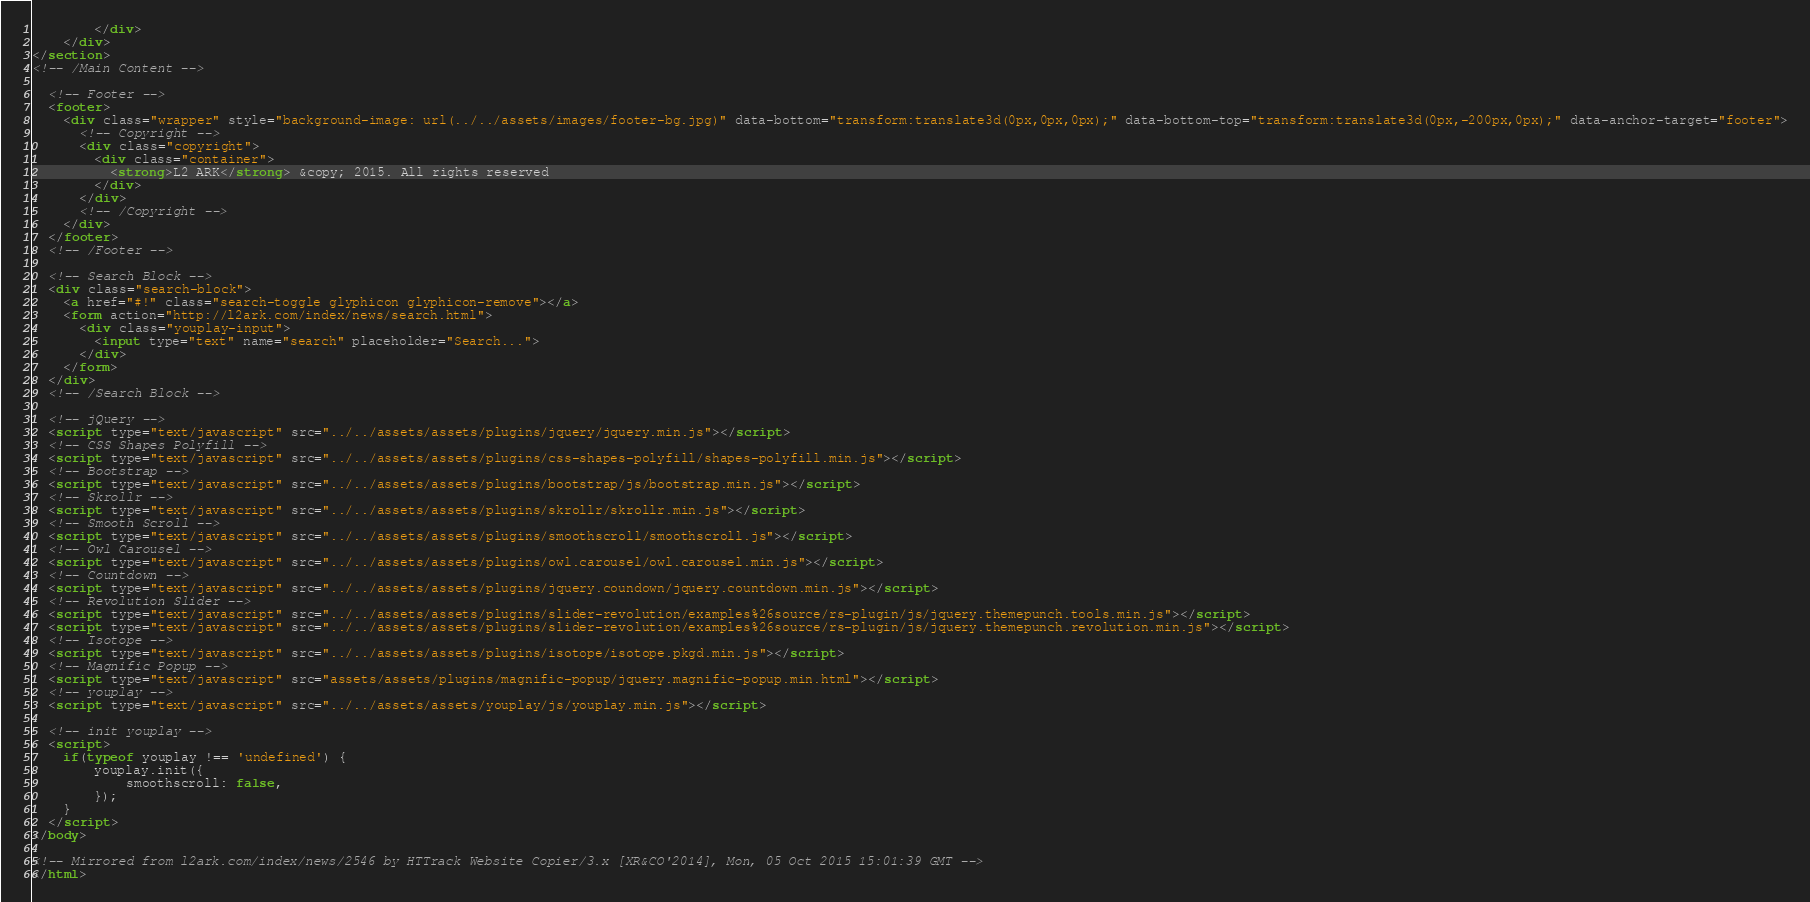Convert code to text. <code><loc_0><loc_0><loc_500><loc_500><_HTML_>        </div>
    </div>
</section>
<!-- /Main Content -->

  <!-- Footer -->
  <footer>
    <div class="wrapper" style="background-image: url(../../assets/images/footer-bg.jpg)" data-bottom="transform:translate3d(0px,0px,0px);" data-bottom-top="transform:translate3d(0px,-200px,0px);" data-anchor-target="footer">
      <!-- Copyright -->
      <div class="copyright">
        <div class="container">
          <strong>L2 ARK</strong> &copy; 2015. All rights reserved
        </div>
      </div>
      <!-- /Copyright -->
    </div>
  </footer>
  <!-- /Footer -->

  <!-- Search Block -->
  <div class="search-block">
    <a href="#!" class="search-toggle glyphicon glyphicon-remove"></a>
    <form action="http://l2ark.com/index/news/search.html">
      <div class="youplay-input">
        <input type="text" name="search" placeholder="Search...">
      </div>
    </form>
  </div>
  <!-- /Search Block -->
  
  <!-- jQuery -->
  <script type="text/javascript" src="../../assets/assets/plugins/jquery/jquery.min.js"></script>
  <!-- CSS Shapes Polyfill -->
  <script type="text/javascript" src="../../assets/assets/plugins/css-shapes-polyfill/shapes-polyfill.min.js"></script>
  <!-- Bootstrap -->
  <script type="text/javascript" src="../../assets/assets/plugins/bootstrap/js/bootstrap.min.js"></script>
  <!-- Skrollr -->
  <script type="text/javascript" src="../../assets/assets/plugins/skrollr/skrollr.min.js"></script>
  <!-- Smooth Scroll -->
  <script type="text/javascript" src="../../assets/assets/plugins/smoothscroll/smoothscroll.js"></script>
  <!-- Owl Carousel -->
  <script type="text/javascript" src="../../assets/assets/plugins/owl.carousel/owl.carousel.min.js"></script>
  <!-- Countdown -->
  <script type="text/javascript" src="../../assets/assets/plugins/jquery.coundown/jquery.countdown.min.js"></script>
  <!-- Revolution Slider -->
  <script type="text/javascript" src="../../assets/assets/plugins/slider-revolution/examples%26source/rs-plugin/js/jquery.themepunch.tools.min.js"></script>
  <script type="text/javascript" src="../../assets/assets/plugins/slider-revolution/examples%26source/rs-plugin/js/jquery.themepunch.revolution.min.js"></script>
  <!-- Isotope -->
  <script type="text/javascript" src="../../assets/assets/plugins/isotope/isotope.pkgd.min.js"></script>
  <!-- Magnific Popup -->
  <script type="text/javascript" src="assets/assets/plugins/magnific-popup/jquery.magnific-popup.min.html"></script>
  <!-- youplay -->
  <script type="text/javascript" src="../../assets/assets/youplay/js/youplay.min.js"></script>

  <!-- init youplay -->
  <script>
    if(typeof youplay !== 'undefined') {
        youplay.init({
            smoothscroll: false,
        });
    }
  </script>
</body>

<!-- Mirrored from l2ark.com/index/news/2546 by HTTrack Website Copier/3.x [XR&CO'2014], Mon, 05 Oct 2015 15:01:39 GMT -->
</html></code> 